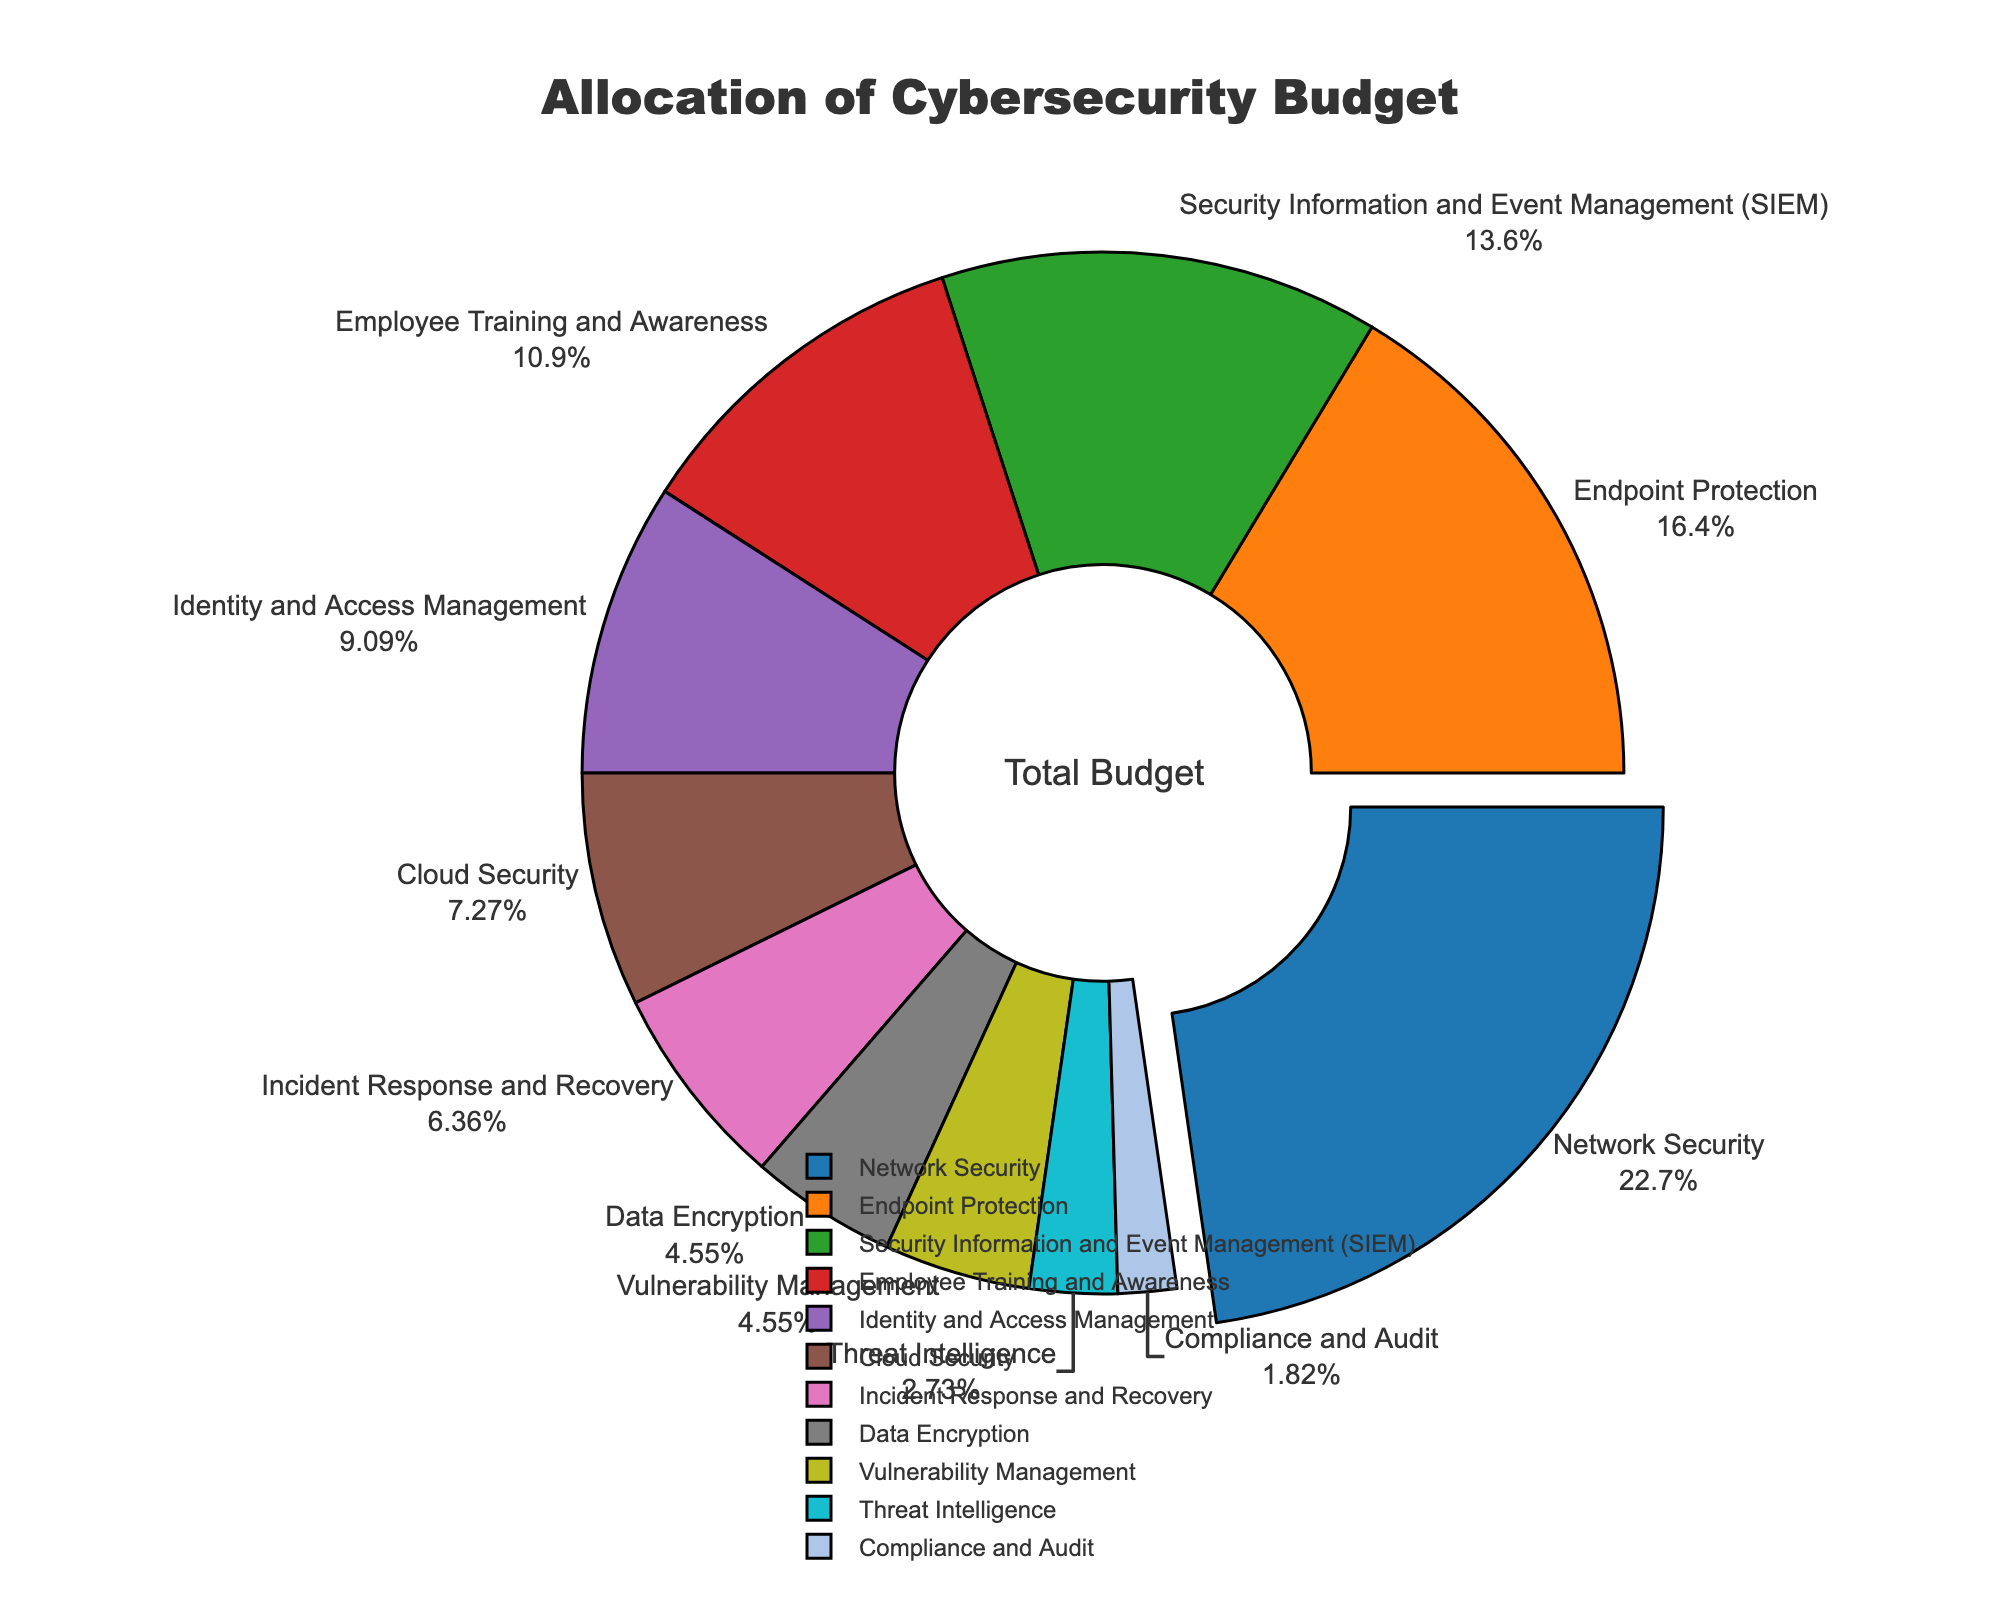Which category has the highest allocation of the cybersecurity budget? The segment that is pulled out the most in the pie chart indicates the highest allocation. In this case, it is Network Security.
Answer: Network Security What is the combined percentage allocation of Employee Training and Awareness and Identity and Access Management? From the chart, Employee Training and Awareness has 12% and Identity and Access Management has 10%. Adding them up gives 12% + 10% = 22%.
Answer: 22% Which category has a smaller allocation, Incident Response and Recovery or Data Encryption? By checking the pie chart, Incident Response and Recovery is at 7% while Data Encryption stands at 5%. Therefore, Data Encryption has a smaller allocation.
Answer: Data Encryption How does the allocation for Endpoint Protection compare to Cloud Security? Endpoint Protection is 18% while Cloud Security is 8%. Therefore, Endpoint Protection's allocation is more than double that of Cloud Security.
Answer: Endpoint Protection is more What is the cumulative allocation percentage for all categories with less than 10%? The categories under 10% are Identity and Access Management (10%), Cloud Security (8%), Incident Response and Recovery (7%), Data Encryption (5%), Vulnerability Management (5%), Threat Intelligence (3%), and Compliance and Audit (2%). Adding them gives 10% + 8% + 7% + 5% + 5% + 3% + 2% = 40%.
Answer: 40% What is the percentage difference between Network Security and Security Information and Event Management (SIEM)? Network Security has a 25% allocation and SIEM has 15%. The difference is 25% - 15% = 10%.
Answer: 10% What are the two categories with the smallest budget allocations, and what is their combined percentage? The two categories with the smallest allocations are Threat Intelligence (3%) and Compliance and Audit (2%). Combined, they make up 3% + 2% = 5%.
Answer: Threat Intelligence and Compliance and Audit; 5% What visual element highlights the category with the highest budget allocation? The pie chart uses a visual technique where the segment representing the category with the highest allocation (Network Security) is 'pulled out' slightly from the rest.
Answer: Segment is pulled out Is the allocation for Data Encryption equal to the sum of the allocations for Threat Intelligence and Compliance and Audit? Data Encryption has 5%, while Threat Intelligence and Compliance and Audit have 3% and 2% respectively. Summing these gives 3% + 2% = 5%, which is equal to Data Encryption's allocation.
Answer: Yes If you add Cloud Security and Endpoint Protection allocations, does it exceed the allocation for Network Security? Cloud Security is 8% and Endpoint Protection is 18%. Summing these gives 8% + 18% = 26%, which is greater than Network Security's 25%.
Answer: Yes 